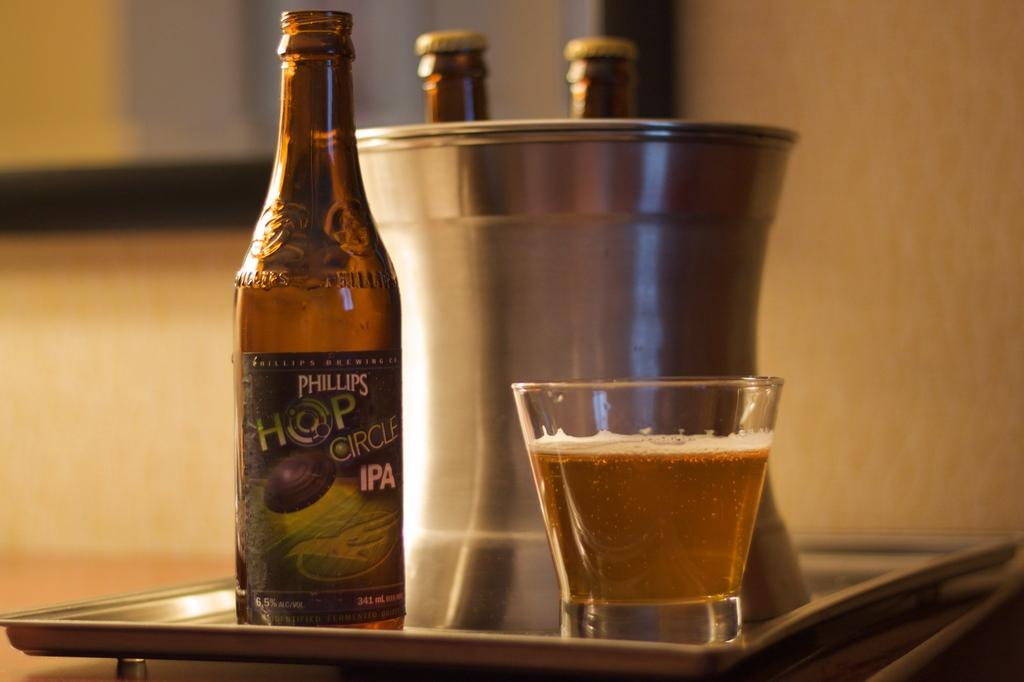What is located in the middle of the image? There is a tray in the middle of the image. What items are on the tray? The tray contains three bottles and a bucket. Is there any liquid container on the tray? Yes, there is a glass with a drink on the tray. What can be seen in the background of the image? There is a window and a wall in the background of the image. What type of quartz can be seen on top of the tray? There is no quartz present on the tray or in the image. How many houses are visible through the window in the background? There is no mention of houses in the image, and the window does not show any houses. 